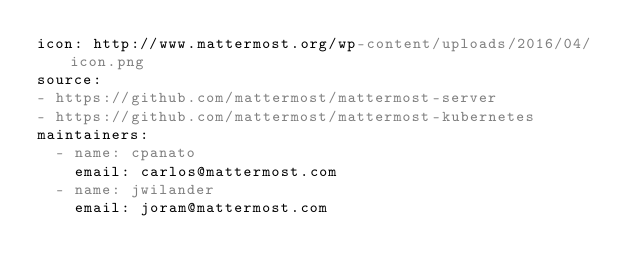<code> <loc_0><loc_0><loc_500><loc_500><_YAML_>icon: http://www.mattermost.org/wp-content/uploads/2016/04/icon.png
source:
- https://github.com/mattermost/mattermost-server
- https://github.com/mattermost/mattermost-kubernetes
maintainers:
  - name: cpanato
    email: carlos@mattermost.com
  - name: jwilander
    email: joram@mattermost.com
</code> 